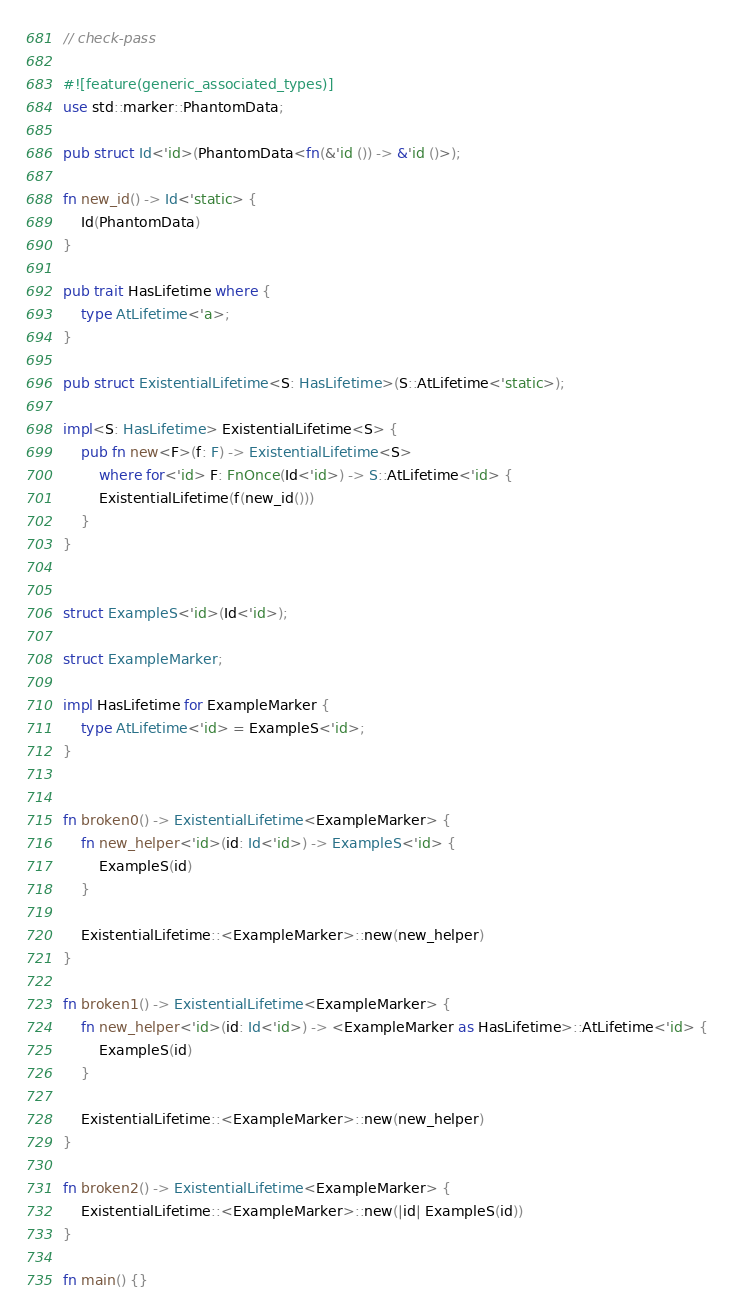<code> <loc_0><loc_0><loc_500><loc_500><_Rust_>// check-pass

#![feature(generic_associated_types)]
use std::marker::PhantomData;

pub struct Id<'id>(PhantomData<fn(&'id ()) -> &'id ()>);

fn new_id() -> Id<'static> {
    Id(PhantomData)
}

pub trait HasLifetime where {
    type AtLifetime<'a>;
}

pub struct ExistentialLifetime<S: HasLifetime>(S::AtLifetime<'static>);

impl<S: HasLifetime> ExistentialLifetime<S> {
    pub fn new<F>(f: F) -> ExistentialLifetime<S>
        where for<'id> F: FnOnce(Id<'id>) -> S::AtLifetime<'id> {
        ExistentialLifetime(f(new_id()))
    }
}


struct ExampleS<'id>(Id<'id>);

struct ExampleMarker;

impl HasLifetime for ExampleMarker {
    type AtLifetime<'id> = ExampleS<'id>;
}


fn broken0() -> ExistentialLifetime<ExampleMarker> {
    fn new_helper<'id>(id: Id<'id>) -> ExampleS<'id> {
        ExampleS(id)
    }

    ExistentialLifetime::<ExampleMarker>::new(new_helper)
}

fn broken1() -> ExistentialLifetime<ExampleMarker> {
    fn new_helper<'id>(id: Id<'id>) -> <ExampleMarker as HasLifetime>::AtLifetime<'id> {
        ExampleS(id)
    }

    ExistentialLifetime::<ExampleMarker>::new(new_helper)
}

fn broken2() -> ExistentialLifetime<ExampleMarker> {
    ExistentialLifetime::<ExampleMarker>::new(|id| ExampleS(id))
}

fn main() {}
</code> 